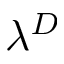<formula> <loc_0><loc_0><loc_500><loc_500>\lambda ^ { D }</formula> 